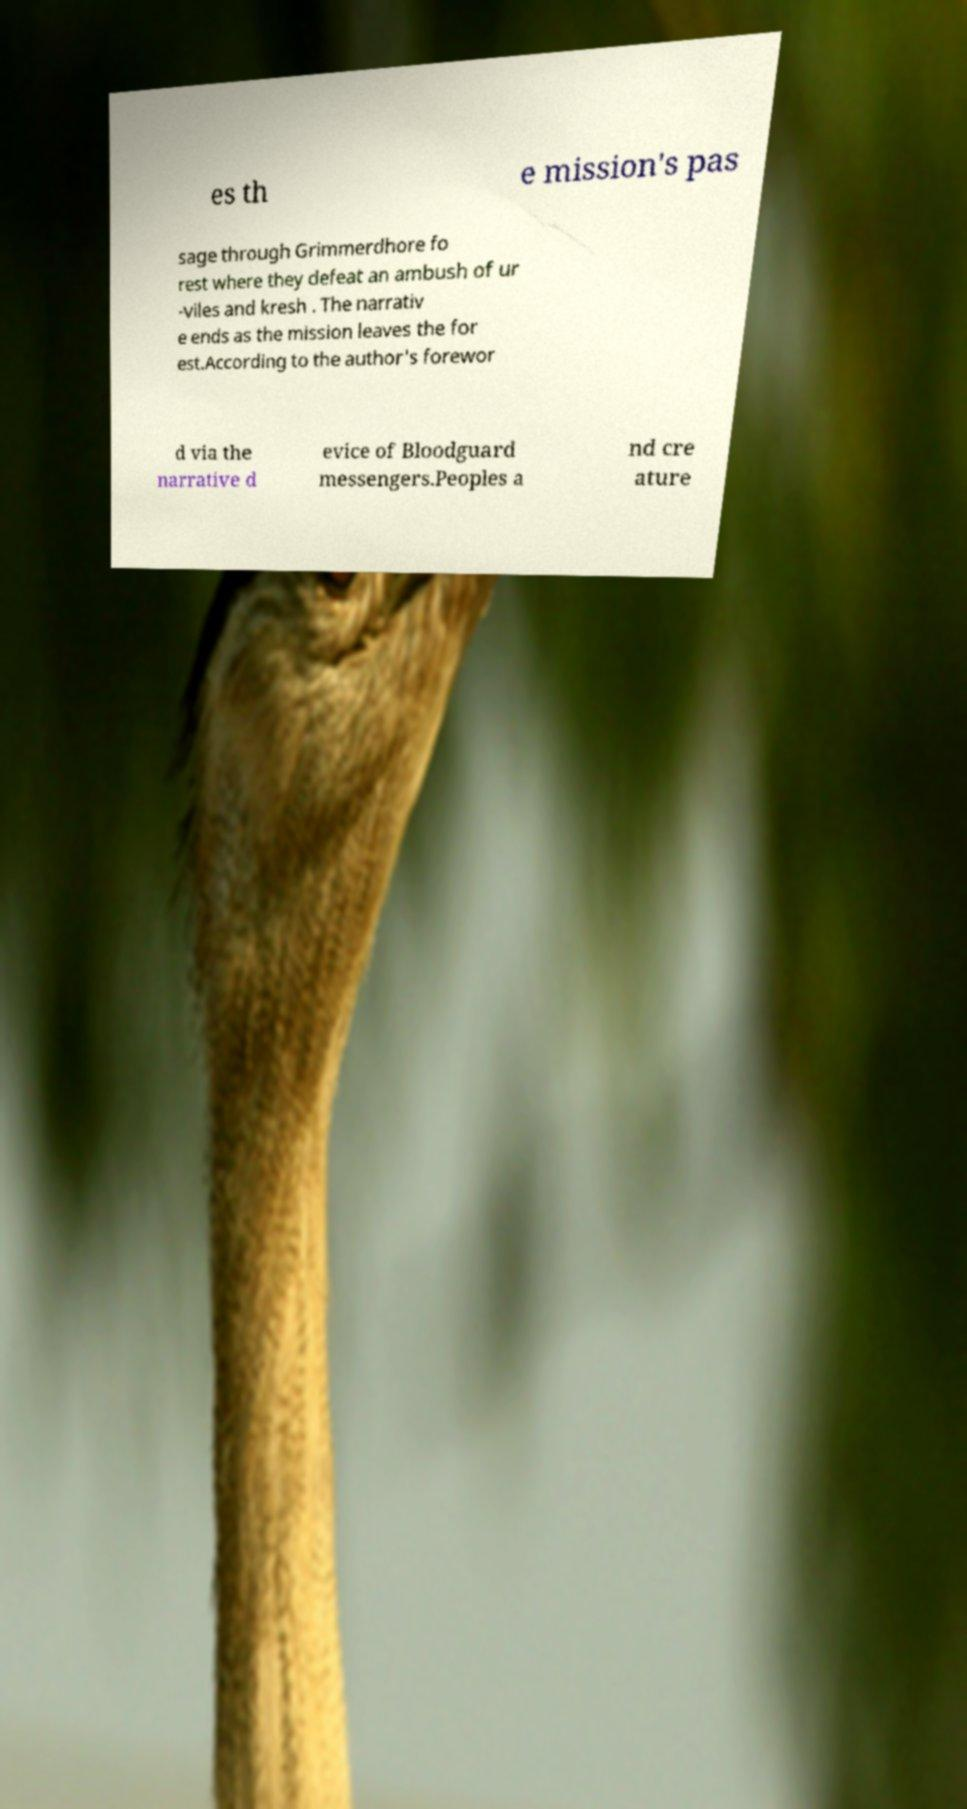For documentation purposes, I need the text within this image transcribed. Could you provide that? es th e mission's pas sage through Grimmerdhore fo rest where they defeat an ambush of ur -viles and kresh . The narrativ e ends as the mission leaves the for est.According to the author's forewor d via the narrative d evice of Bloodguard messengers.Peoples a nd cre ature 